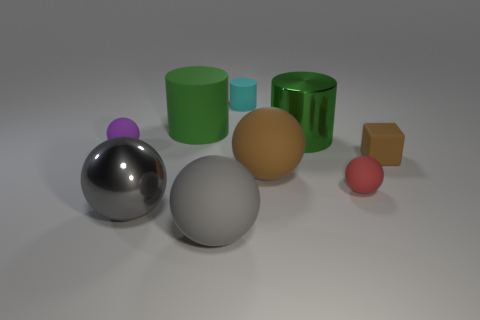Is the number of green things that are behind the tiny matte cylinder the same as the number of small purple cubes?
Offer a terse response. Yes. Are there any other things that have the same material as the small purple object?
Make the answer very short. Yes. Is the small thing that is behind the tiny purple matte thing made of the same material as the small block?
Offer a terse response. Yes. Is the number of rubber spheres that are on the right side of the tiny red matte thing less than the number of large matte things?
Give a very brief answer. Yes. What number of matte things are tiny red balls or big brown balls?
Provide a short and direct response. 2. Is the big metal sphere the same color as the metallic cylinder?
Offer a terse response. No. Is there any other thing of the same color as the big metallic ball?
Ensure brevity in your answer.  Yes. Does the large metal object behind the purple ball have the same shape as the gray thing that is in front of the gray metal ball?
Your answer should be compact. No. What number of objects are gray things or gray objects that are in front of the tiny brown matte block?
Give a very brief answer. 2. What number of other things are the same size as the green rubber cylinder?
Provide a short and direct response. 4. 